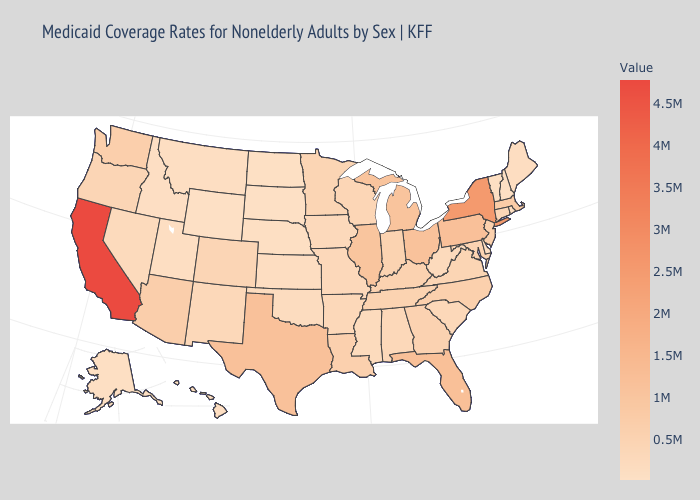Does California have the highest value in the USA?
Write a very short answer. Yes. Among the states that border Missouri , does Tennessee have the lowest value?
Short answer required. No. Does North Dakota have the lowest value in the MidWest?
Give a very brief answer. No. Does New Jersey have the lowest value in the Northeast?
Answer briefly. No. Which states have the highest value in the USA?
Give a very brief answer. California. Does Wyoming have the highest value in the West?
Concise answer only. No. Which states have the lowest value in the South?
Short answer required. Delaware. 